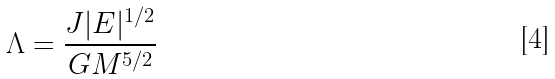<formula> <loc_0><loc_0><loc_500><loc_500>\Lambda = \frac { J | E | ^ { 1 / 2 } } { G M ^ { 5 / 2 } }</formula> 